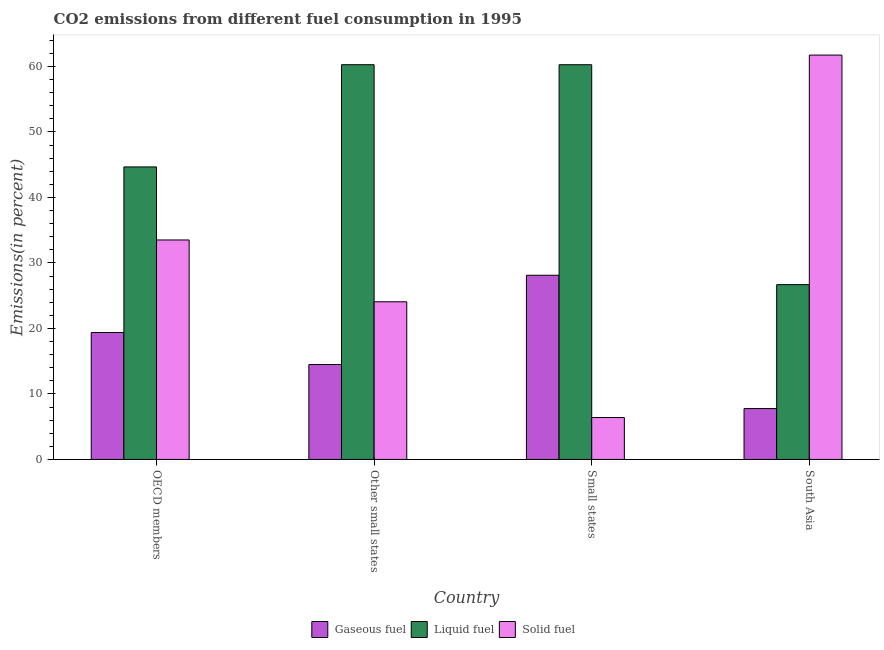Are the number of bars on each tick of the X-axis equal?
Your response must be concise. Yes. How many bars are there on the 4th tick from the left?
Your answer should be compact. 3. How many bars are there on the 1st tick from the right?
Your response must be concise. 3. What is the label of the 1st group of bars from the left?
Your answer should be compact. OECD members. What is the percentage of liquid fuel emission in South Asia?
Keep it short and to the point. 26.69. Across all countries, what is the maximum percentage of solid fuel emission?
Make the answer very short. 61.74. Across all countries, what is the minimum percentage of solid fuel emission?
Offer a very short reply. 6.4. In which country was the percentage of gaseous fuel emission maximum?
Ensure brevity in your answer.  Small states. In which country was the percentage of liquid fuel emission minimum?
Provide a short and direct response. South Asia. What is the total percentage of solid fuel emission in the graph?
Ensure brevity in your answer.  125.73. What is the difference between the percentage of gaseous fuel emission in Other small states and that in South Asia?
Your answer should be very brief. 6.72. What is the difference between the percentage of solid fuel emission in OECD members and the percentage of gaseous fuel emission in South Asia?
Give a very brief answer. 25.74. What is the average percentage of gaseous fuel emission per country?
Give a very brief answer. 17.44. What is the difference between the percentage of solid fuel emission and percentage of liquid fuel emission in OECD members?
Keep it short and to the point. -11.15. What is the ratio of the percentage of solid fuel emission in Other small states to that in South Asia?
Ensure brevity in your answer.  0.39. Is the difference between the percentage of liquid fuel emission in Other small states and South Asia greater than the difference between the percentage of solid fuel emission in Other small states and South Asia?
Your answer should be very brief. Yes. What is the difference between the highest and the second highest percentage of solid fuel emission?
Keep it short and to the point. 28.23. What is the difference between the highest and the lowest percentage of solid fuel emission?
Make the answer very short. 55.34. In how many countries, is the percentage of liquid fuel emission greater than the average percentage of liquid fuel emission taken over all countries?
Offer a very short reply. 2. Is the sum of the percentage of solid fuel emission in OECD members and Small states greater than the maximum percentage of liquid fuel emission across all countries?
Your answer should be very brief. No. What does the 2nd bar from the left in South Asia represents?
Your answer should be very brief. Liquid fuel. What does the 1st bar from the right in Other small states represents?
Keep it short and to the point. Solid fuel. How many bars are there?
Make the answer very short. 12. Are all the bars in the graph horizontal?
Offer a very short reply. No. What is the difference between two consecutive major ticks on the Y-axis?
Offer a very short reply. 10. Does the graph contain any zero values?
Make the answer very short. No. Does the graph contain grids?
Keep it short and to the point. No. Where does the legend appear in the graph?
Keep it short and to the point. Bottom center. How many legend labels are there?
Ensure brevity in your answer.  3. What is the title of the graph?
Provide a succinct answer. CO2 emissions from different fuel consumption in 1995. What is the label or title of the X-axis?
Your answer should be compact. Country. What is the label or title of the Y-axis?
Keep it short and to the point. Emissions(in percent). What is the Emissions(in percent) of Gaseous fuel in OECD members?
Give a very brief answer. 19.39. What is the Emissions(in percent) of Liquid fuel in OECD members?
Make the answer very short. 44.66. What is the Emissions(in percent) in Solid fuel in OECD members?
Your answer should be very brief. 33.51. What is the Emissions(in percent) of Gaseous fuel in Other small states?
Give a very brief answer. 14.49. What is the Emissions(in percent) of Liquid fuel in Other small states?
Offer a terse response. 60.27. What is the Emissions(in percent) in Solid fuel in Other small states?
Offer a very short reply. 24.08. What is the Emissions(in percent) in Gaseous fuel in Small states?
Offer a very short reply. 28.13. What is the Emissions(in percent) in Liquid fuel in Small states?
Your answer should be compact. 60.27. What is the Emissions(in percent) of Solid fuel in Small states?
Your answer should be compact. 6.4. What is the Emissions(in percent) of Gaseous fuel in South Asia?
Offer a terse response. 7.77. What is the Emissions(in percent) of Liquid fuel in South Asia?
Offer a very short reply. 26.69. What is the Emissions(in percent) of Solid fuel in South Asia?
Offer a terse response. 61.74. Across all countries, what is the maximum Emissions(in percent) in Gaseous fuel?
Offer a terse response. 28.13. Across all countries, what is the maximum Emissions(in percent) in Liquid fuel?
Offer a very short reply. 60.27. Across all countries, what is the maximum Emissions(in percent) in Solid fuel?
Make the answer very short. 61.74. Across all countries, what is the minimum Emissions(in percent) of Gaseous fuel?
Keep it short and to the point. 7.77. Across all countries, what is the minimum Emissions(in percent) of Liquid fuel?
Ensure brevity in your answer.  26.69. Across all countries, what is the minimum Emissions(in percent) in Solid fuel?
Your answer should be very brief. 6.4. What is the total Emissions(in percent) of Gaseous fuel in the graph?
Offer a terse response. 69.78. What is the total Emissions(in percent) of Liquid fuel in the graph?
Your answer should be very brief. 191.9. What is the total Emissions(in percent) in Solid fuel in the graph?
Offer a terse response. 125.73. What is the difference between the Emissions(in percent) in Gaseous fuel in OECD members and that in Other small states?
Your answer should be compact. 4.89. What is the difference between the Emissions(in percent) of Liquid fuel in OECD members and that in Other small states?
Your answer should be very brief. -15.61. What is the difference between the Emissions(in percent) of Solid fuel in OECD members and that in Other small states?
Your answer should be compact. 9.44. What is the difference between the Emissions(in percent) in Gaseous fuel in OECD members and that in Small states?
Make the answer very short. -8.74. What is the difference between the Emissions(in percent) in Liquid fuel in OECD members and that in Small states?
Your answer should be very brief. -15.61. What is the difference between the Emissions(in percent) of Solid fuel in OECD members and that in Small states?
Keep it short and to the point. 27.11. What is the difference between the Emissions(in percent) in Gaseous fuel in OECD members and that in South Asia?
Ensure brevity in your answer.  11.62. What is the difference between the Emissions(in percent) in Liquid fuel in OECD members and that in South Asia?
Make the answer very short. 17.97. What is the difference between the Emissions(in percent) in Solid fuel in OECD members and that in South Asia?
Your answer should be very brief. -28.23. What is the difference between the Emissions(in percent) of Gaseous fuel in Other small states and that in Small states?
Your response must be concise. -13.63. What is the difference between the Emissions(in percent) in Liquid fuel in Other small states and that in Small states?
Give a very brief answer. 0. What is the difference between the Emissions(in percent) of Solid fuel in Other small states and that in Small states?
Offer a very short reply. 17.68. What is the difference between the Emissions(in percent) in Gaseous fuel in Other small states and that in South Asia?
Keep it short and to the point. 6.72. What is the difference between the Emissions(in percent) of Liquid fuel in Other small states and that in South Asia?
Keep it short and to the point. 33.58. What is the difference between the Emissions(in percent) of Solid fuel in Other small states and that in South Asia?
Offer a very short reply. -37.66. What is the difference between the Emissions(in percent) in Gaseous fuel in Small states and that in South Asia?
Your answer should be very brief. 20.36. What is the difference between the Emissions(in percent) in Liquid fuel in Small states and that in South Asia?
Your answer should be very brief. 33.58. What is the difference between the Emissions(in percent) in Solid fuel in Small states and that in South Asia?
Provide a short and direct response. -55.34. What is the difference between the Emissions(in percent) in Gaseous fuel in OECD members and the Emissions(in percent) in Liquid fuel in Other small states?
Your answer should be compact. -40.88. What is the difference between the Emissions(in percent) of Gaseous fuel in OECD members and the Emissions(in percent) of Solid fuel in Other small states?
Keep it short and to the point. -4.69. What is the difference between the Emissions(in percent) in Liquid fuel in OECD members and the Emissions(in percent) in Solid fuel in Other small states?
Provide a short and direct response. 20.59. What is the difference between the Emissions(in percent) in Gaseous fuel in OECD members and the Emissions(in percent) in Liquid fuel in Small states?
Make the answer very short. -40.88. What is the difference between the Emissions(in percent) in Gaseous fuel in OECD members and the Emissions(in percent) in Solid fuel in Small states?
Give a very brief answer. 12.99. What is the difference between the Emissions(in percent) of Liquid fuel in OECD members and the Emissions(in percent) of Solid fuel in Small states?
Keep it short and to the point. 38.26. What is the difference between the Emissions(in percent) of Gaseous fuel in OECD members and the Emissions(in percent) of Liquid fuel in South Asia?
Offer a terse response. -7.31. What is the difference between the Emissions(in percent) in Gaseous fuel in OECD members and the Emissions(in percent) in Solid fuel in South Asia?
Make the answer very short. -42.35. What is the difference between the Emissions(in percent) of Liquid fuel in OECD members and the Emissions(in percent) of Solid fuel in South Asia?
Your answer should be very brief. -17.08. What is the difference between the Emissions(in percent) of Gaseous fuel in Other small states and the Emissions(in percent) of Liquid fuel in Small states?
Ensure brevity in your answer.  -45.77. What is the difference between the Emissions(in percent) in Gaseous fuel in Other small states and the Emissions(in percent) in Solid fuel in Small states?
Offer a terse response. 8.1. What is the difference between the Emissions(in percent) of Liquid fuel in Other small states and the Emissions(in percent) of Solid fuel in Small states?
Give a very brief answer. 53.87. What is the difference between the Emissions(in percent) in Gaseous fuel in Other small states and the Emissions(in percent) in Liquid fuel in South Asia?
Offer a terse response. -12.2. What is the difference between the Emissions(in percent) of Gaseous fuel in Other small states and the Emissions(in percent) of Solid fuel in South Asia?
Make the answer very short. -47.25. What is the difference between the Emissions(in percent) of Liquid fuel in Other small states and the Emissions(in percent) of Solid fuel in South Asia?
Ensure brevity in your answer.  -1.47. What is the difference between the Emissions(in percent) in Gaseous fuel in Small states and the Emissions(in percent) in Liquid fuel in South Asia?
Keep it short and to the point. 1.43. What is the difference between the Emissions(in percent) of Gaseous fuel in Small states and the Emissions(in percent) of Solid fuel in South Asia?
Your response must be concise. -33.61. What is the difference between the Emissions(in percent) in Liquid fuel in Small states and the Emissions(in percent) in Solid fuel in South Asia?
Give a very brief answer. -1.47. What is the average Emissions(in percent) of Gaseous fuel per country?
Provide a short and direct response. 17.44. What is the average Emissions(in percent) in Liquid fuel per country?
Keep it short and to the point. 47.97. What is the average Emissions(in percent) of Solid fuel per country?
Your response must be concise. 31.43. What is the difference between the Emissions(in percent) of Gaseous fuel and Emissions(in percent) of Liquid fuel in OECD members?
Keep it short and to the point. -25.28. What is the difference between the Emissions(in percent) in Gaseous fuel and Emissions(in percent) in Solid fuel in OECD members?
Ensure brevity in your answer.  -14.13. What is the difference between the Emissions(in percent) in Liquid fuel and Emissions(in percent) in Solid fuel in OECD members?
Keep it short and to the point. 11.15. What is the difference between the Emissions(in percent) in Gaseous fuel and Emissions(in percent) in Liquid fuel in Other small states?
Your response must be concise. -45.78. What is the difference between the Emissions(in percent) in Gaseous fuel and Emissions(in percent) in Solid fuel in Other small states?
Your response must be concise. -9.58. What is the difference between the Emissions(in percent) of Liquid fuel and Emissions(in percent) of Solid fuel in Other small states?
Provide a succinct answer. 36.2. What is the difference between the Emissions(in percent) in Gaseous fuel and Emissions(in percent) in Liquid fuel in Small states?
Keep it short and to the point. -32.14. What is the difference between the Emissions(in percent) of Gaseous fuel and Emissions(in percent) of Solid fuel in Small states?
Your answer should be compact. 21.73. What is the difference between the Emissions(in percent) of Liquid fuel and Emissions(in percent) of Solid fuel in Small states?
Keep it short and to the point. 53.87. What is the difference between the Emissions(in percent) in Gaseous fuel and Emissions(in percent) in Liquid fuel in South Asia?
Your answer should be very brief. -18.92. What is the difference between the Emissions(in percent) of Gaseous fuel and Emissions(in percent) of Solid fuel in South Asia?
Your answer should be very brief. -53.97. What is the difference between the Emissions(in percent) in Liquid fuel and Emissions(in percent) in Solid fuel in South Asia?
Keep it short and to the point. -35.05. What is the ratio of the Emissions(in percent) of Gaseous fuel in OECD members to that in Other small states?
Keep it short and to the point. 1.34. What is the ratio of the Emissions(in percent) in Liquid fuel in OECD members to that in Other small states?
Your response must be concise. 0.74. What is the ratio of the Emissions(in percent) in Solid fuel in OECD members to that in Other small states?
Your response must be concise. 1.39. What is the ratio of the Emissions(in percent) in Gaseous fuel in OECD members to that in Small states?
Give a very brief answer. 0.69. What is the ratio of the Emissions(in percent) in Liquid fuel in OECD members to that in Small states?
Give a very brief answer. 0.74. What is the ratio of the Emissions(in percent) of Solid fuel in OECD members to that in Small states?
Provide a succinct answer. 5.24. What is the ratio of the Emissions(in percent) of Gaseous fuel in OECD members to that in South Asia?
Give a very brief answer. 2.5. What is the ratio of the Emissions(in percent) in Liquid fuel in OECD members to that in South Asia?
Offer a very short reply. 1.67. What is the ratio of the Emissions(in percent) in Solid fuel in OECD members to that in South Asia?
Provide a succinct answer. 0.54. What is the ratio of the Emissions(in percent) of Gaseous fuel in Other small states to that in Small states?
Make the answer very short. 0.52. What is the ratio of the Emissions(in percent) of Solid fuel in Other small states to that in Small states?
Provide a succinct answer. 3.76. What is the ratio of the Emissions(in percent) of Gaseous fuel in Other small states to that in South Asia?
Give a very brief answer. 1.87. What is the ratio of the Emissions(in percent) in Liquid fuel in Other small states to that in South Asia?
Your answer should be very brief. 2.26. What is the ratio of the Emissions(in percent) of Solid fuel in Other small states to that in South Asia?
Offer a terse response. 0.39. What is the ratio of the Emissions(in percent) of Gaseous fuel in Small states to that in South Asia?
Offer a terse response. 3.62. What is the ratio of the Emissions(in percent) of Liquid fuel in Small states to that in South Asia?
Keep it short and to the point. 2.26. What is the ratio of the Emissions(in percent) in Solid fuel in Small states to that in South Asia?
Keep it short and to the point. 0.1. What is the difference between the highest and the second highest Emissions(in percent) of Gaseous fuel?
Keep it short and to the point. 8.74. What is the difference between the highest and the second highest Emissions(in percent) in Liquid fuel?
Provide a succinct answer. 0. What is the difference between the highest and the second highest Emissions(in percent) of Solid fuel?
Make the answer very short. 28.23. What is the difference between the highest and the lowest Emissions(in percent) in Gaseous fuel?
Provide a succinct answer. 20.36. What is the difference between the highest and the lowest Emissions(in percent) of Liquid fuel?
Give a very brief answer. 33.58. What is the difference between the highest and the lowest Emissions(in percent) of Solid fuel?
Offer a very short reply. 55.34. 